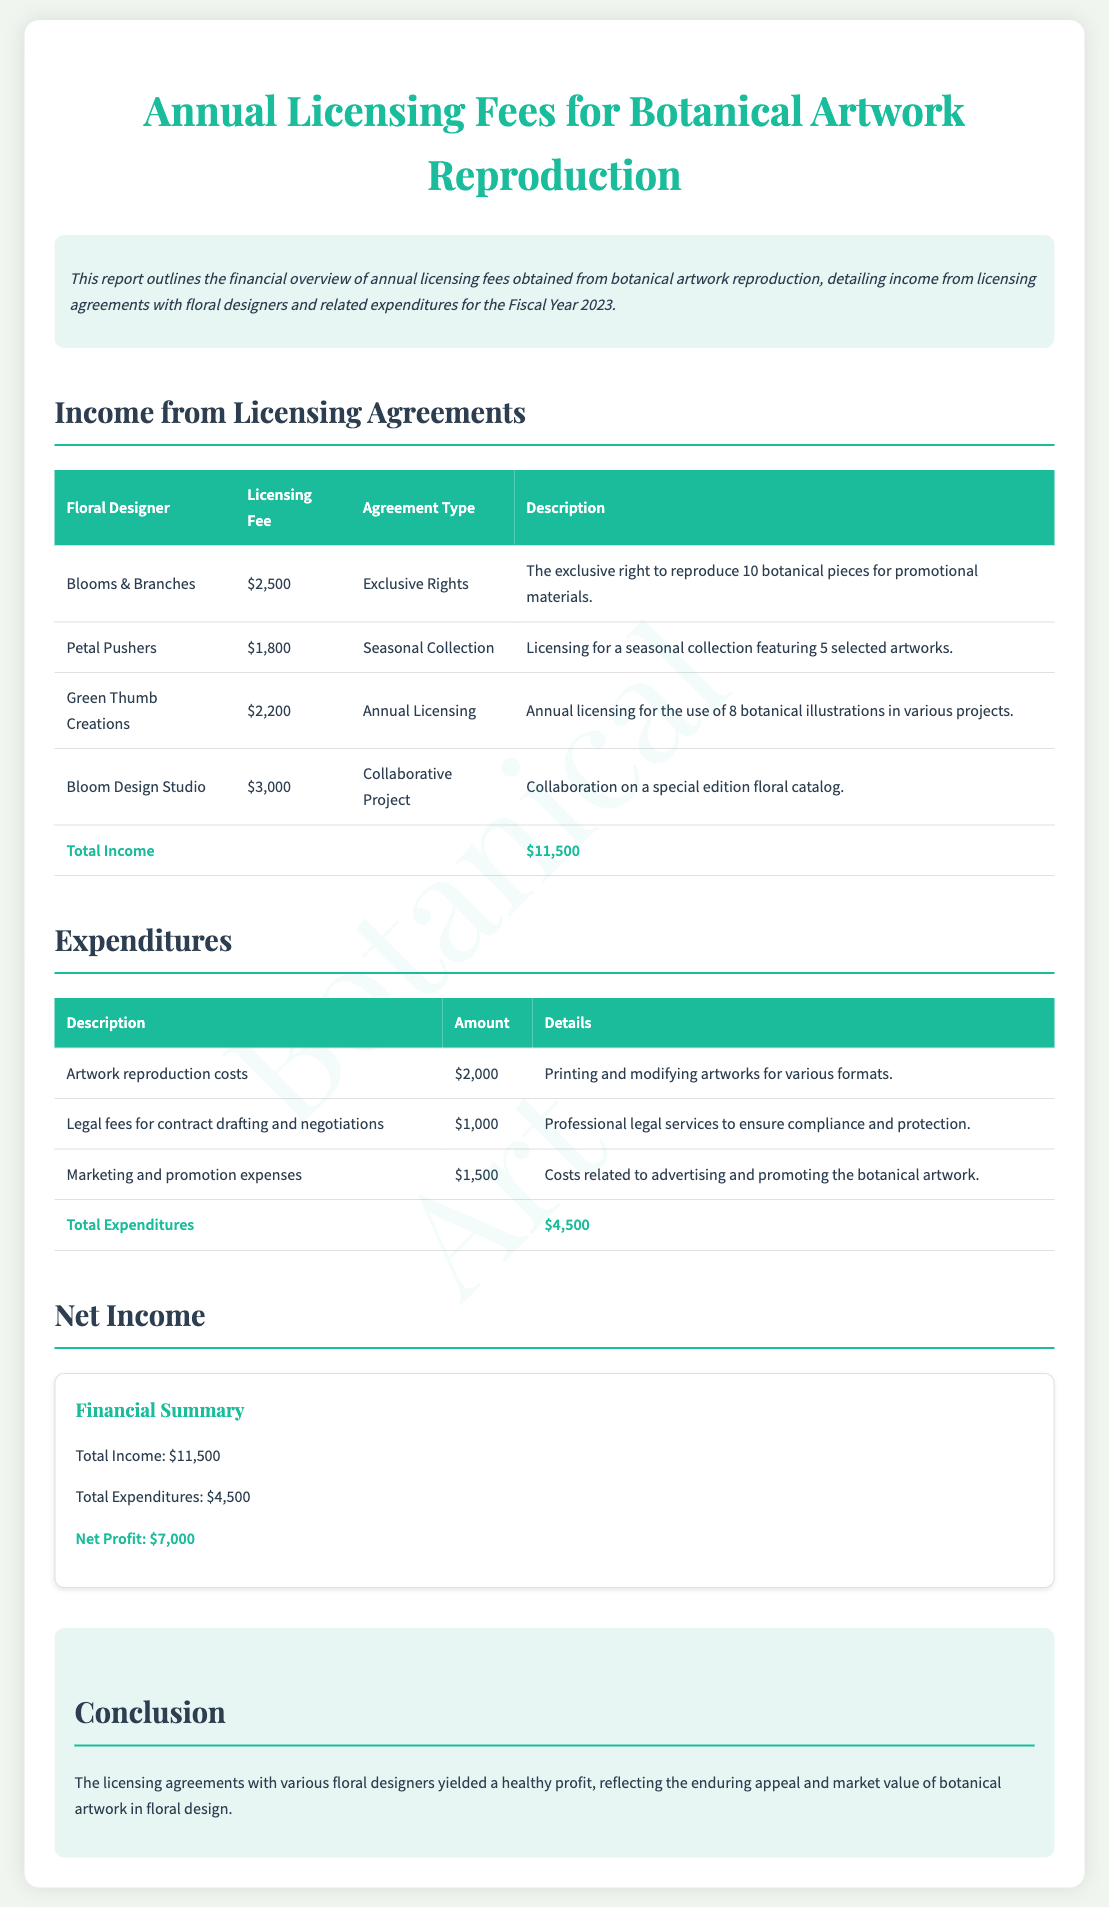What is the total income? The total income is calculated by adding all the licensing fees listed in the document, which sums up to $11,500.
Answer: $11,500 What is the net profit for Fiscal Year 2023? The net profit is derived from the total income minus the total expenditures, which is $11,500 - $4,500 = $7,000.
Answer: $7,000 Which floral designer had the highest licensing fee? The floral designer with the highest licensing fee is Bloom Design Studio, which charged $3,000 for their services.
Answer: Bloom Design Studio What is the total amount spent on marketing and promotion expenses? The document details that marketing and promotion expenses amounted to $1,500, making it a specific expenditure item.
Answer: $1,500 What type of licensing agreement does Green Thumb Creations have? The type of licensing agreement for Green Thumb Creations is an Annual Licensing agreement as stated in the table.
Answer: Annual Licensing How much was spent on legal fees? The document explicitly mentions that the legal fees for contract drafting and negotiations total $1,000.
Answer: $1,000 What is the description for the licensing agreement with Petal Pushers? The description for Petal Pushers indicates licensing for a seasonal collection featuring 5 selected artworks.
Answer: Seasonal collection featuring 5 selected artworks What is the total expenditure listed in the report? The total expenditure is presented as the sum of all expenditures in the expenditures table, which totals $4,500.
Answer: $4,500 What year does the financial report cover? The financial report is specifically for Fiscal Year 2023, as mentioned in the introduction summary.
Answer: 2023 